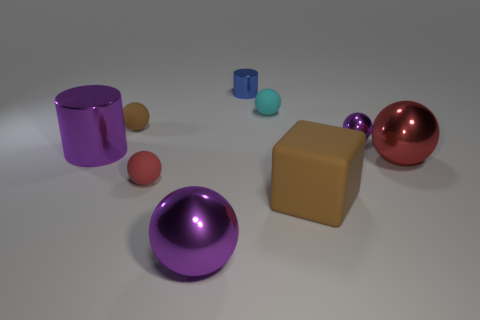Is there anything else that has the same shape as the big brown thing?
Provide a succinct answer. No. How many large cylinders are there?
Provide a succinct answer. 1. There is a small matte object right of the blue metal thing; what color is it?
Ensure brevity in your answer.  Cyan. What color is the big ball in front of the large ball that is behind the large brown rubber block?
Your answer should be compact. Purple. There is a metallic thing that is the same size as the blue cylinder; what is its color?
Provide a succinct answer. Purple. How many rubber things are both behind the big brown rubber block and right of the small cyan rubber thing?
Ensure brevity in your answer.  0. There is a tiny thing that is the same color as the big cylinder; what is its shape?
Offer a very short reply. Sphere. There is a small thing that is both behind the brown sphere and in front of the blue object; what material is it?
Keep it short and to the point. Rubber. Are there fewer tiny blue objects that are behind the large purple metallic cylinder than metal cylinders that are to the right of the red rubber ball?
Keep it short and to the point. No. There is a cylinder that is made of the same material as the blue thing; what is its size?
Your response must be concise. Large. 